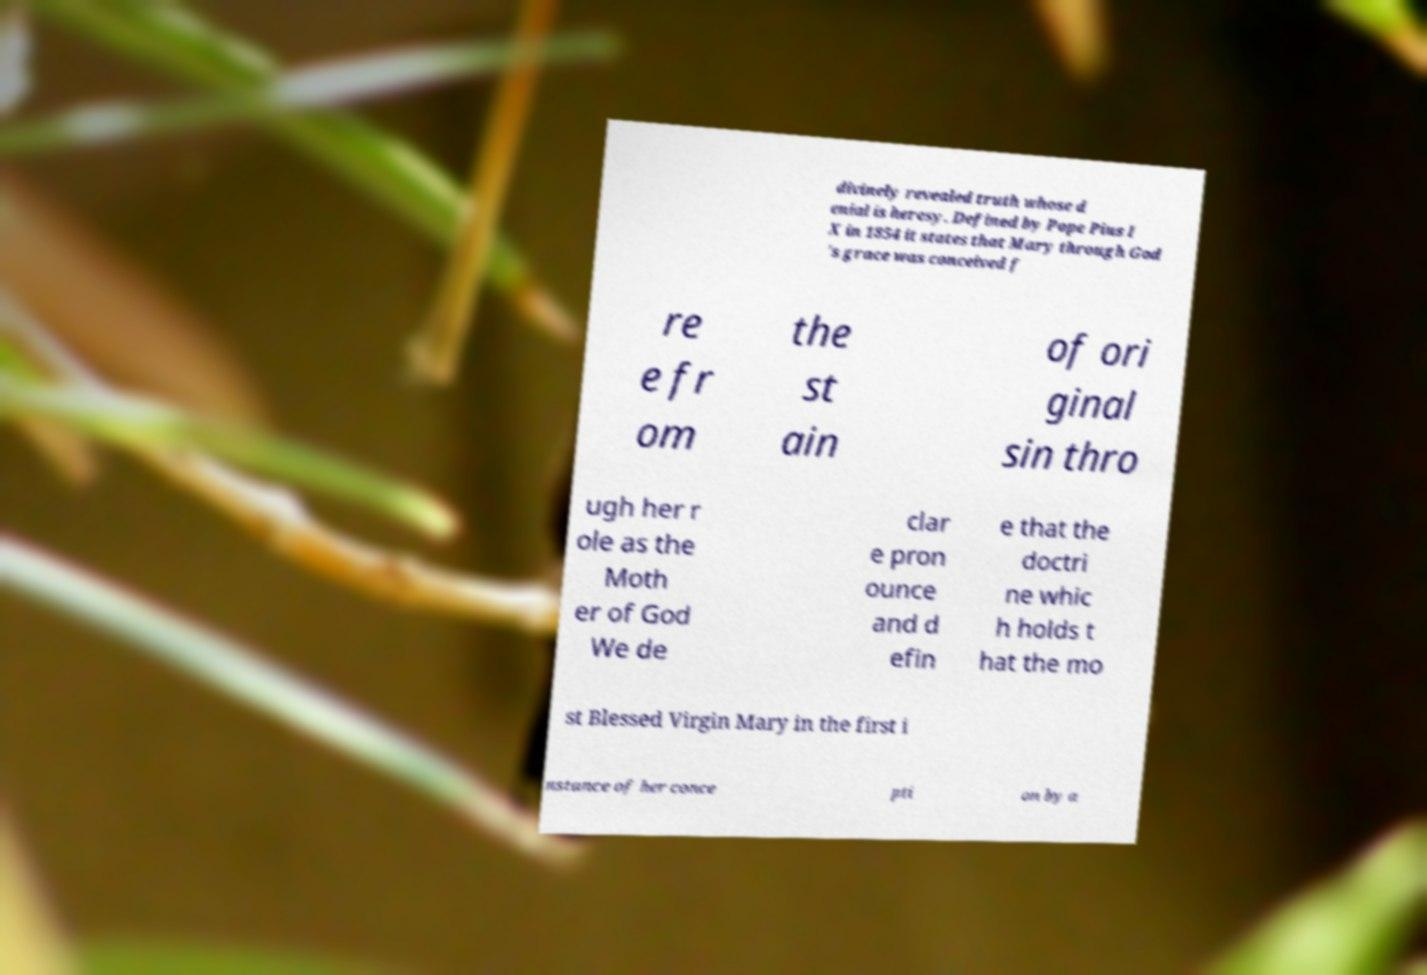For documentation purposes, I need the text within this image transcribed. Could you provide that? divinely revealed truth whose d enial is heresy. Defined by Pope Pius I X in 1854 it states that Mary through God 's grace was conceived f re e fr om the st ain of ori ginal sin thro ugh her r ole as the Moth er of God We de clar e pron ounce and d efin e that the doctri ne whic h holds t hat the mo st Blessed Virgin Mary in the first i nstance of her conce pti on by a 